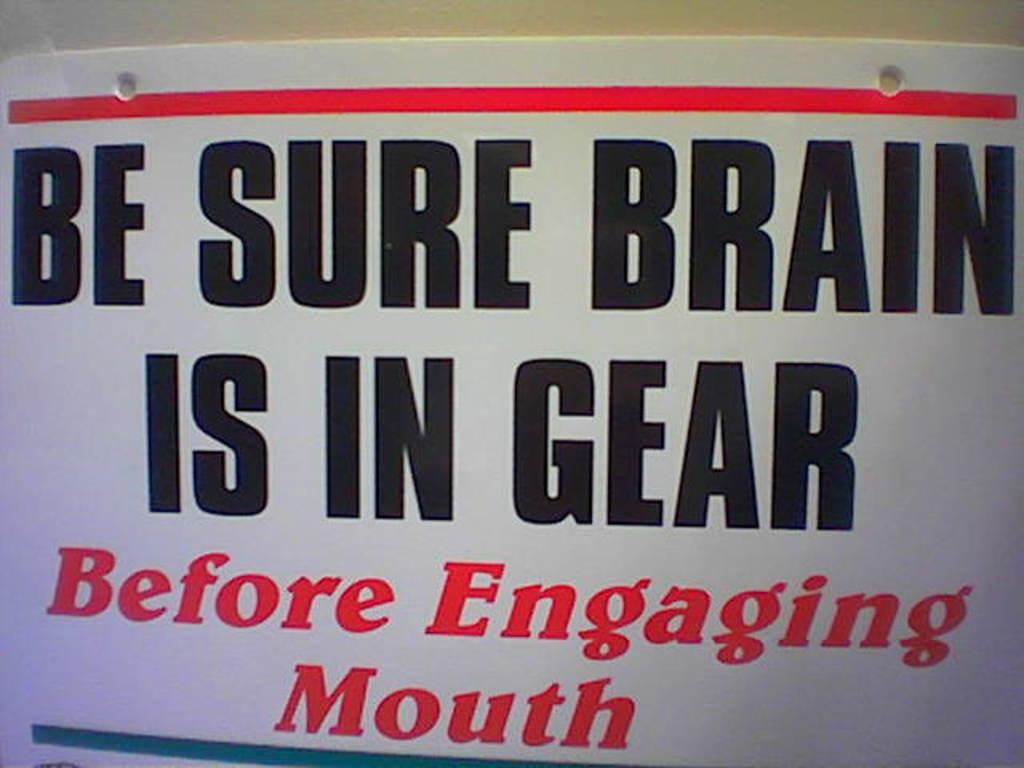What should be in gear?
Provide a succinct answer. Brain. Is this sign asking for you to be cautious?
Make the answer very short. Yes. 